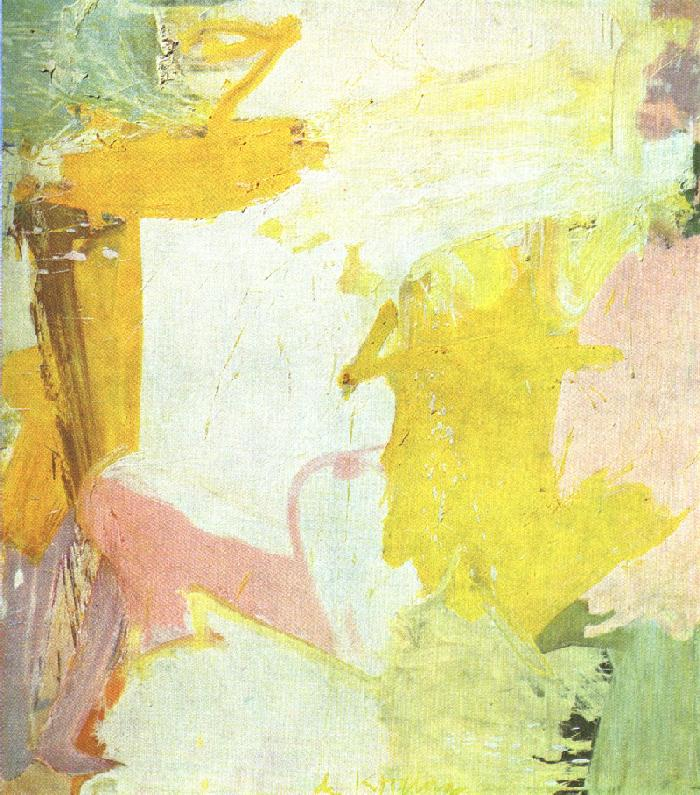Can you describe the techniques used by the artist in this painting? Certainly, the artist utilized a range of techniques, including impasto, where thick layers of paint are applied to create texture and relief. The brushwork is expressive, with varying directions and strokes that enhance the dynamic nature of the composition. There's also a transparency in some areas where the canvas is exposed, giving a sense of layering and depth to the artwork. 